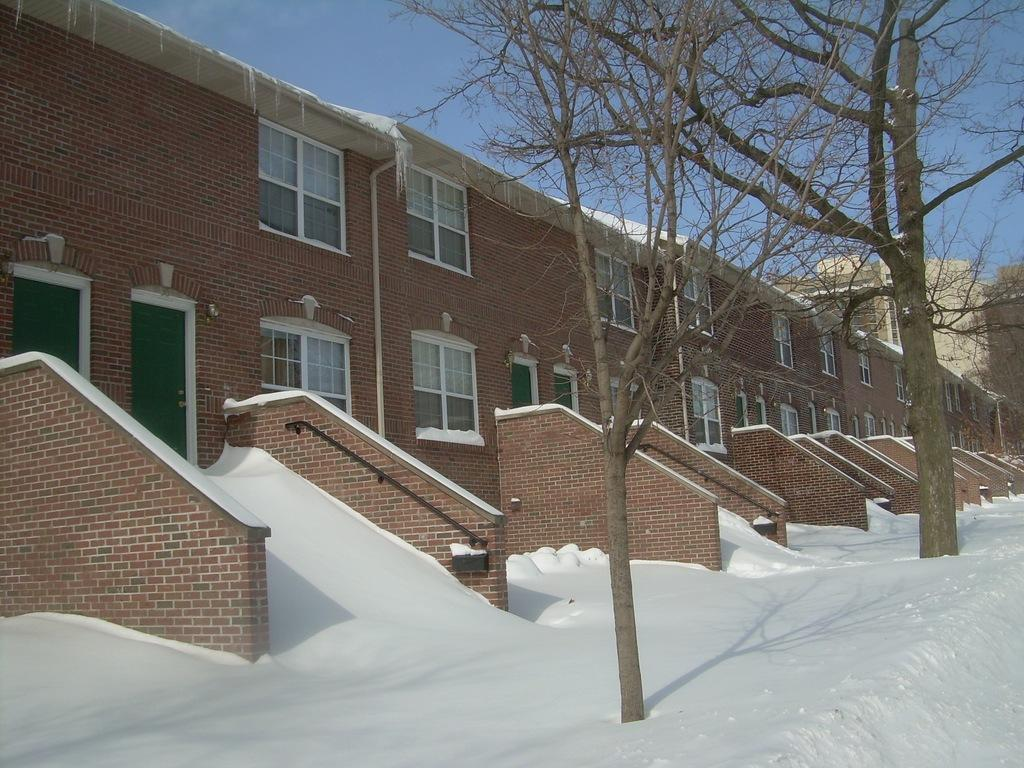What type of structures are present in the image? The image contains buildings. What features can be observed on the buildings? The buildings have windows and doors. What is the ground condition at the bottom of the image? There is snow at the bottom of the image. What type of vegetation is present in the middle of the image? There are trees in the middle of the image. Can you tell me how many jellyfish are swimming in the image? There are no jellyfish present in the image; it features buildings, snow, and trees. 